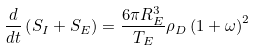<formula> <loc_0><loc_0><loc_500><loc_500>\frac { d } { d t } \left ( S _ { I } + S _ { E } \right ) = \frac { 6 \pi R _ { E } ^ { 3 } } { T _ { E } } \rho _ { D } \left ( 1 + \omega \right ) ^ { 2 }</formula> 